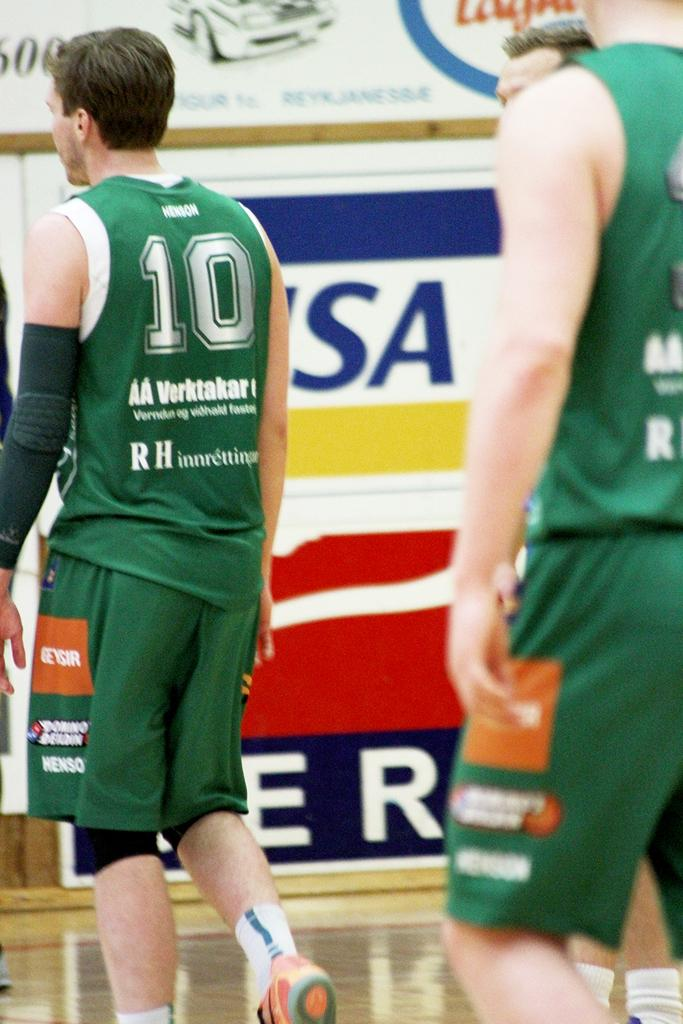Provide a one-sentence caption for the provided image. Player wearing a green number 10 jersey walking on a basketball court. 